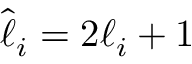<formula> <loc_0><loc_0><loc_500><loc_500>\hat { \ell } _ { i } = 2 \ell _ { i } + 1</formula> 